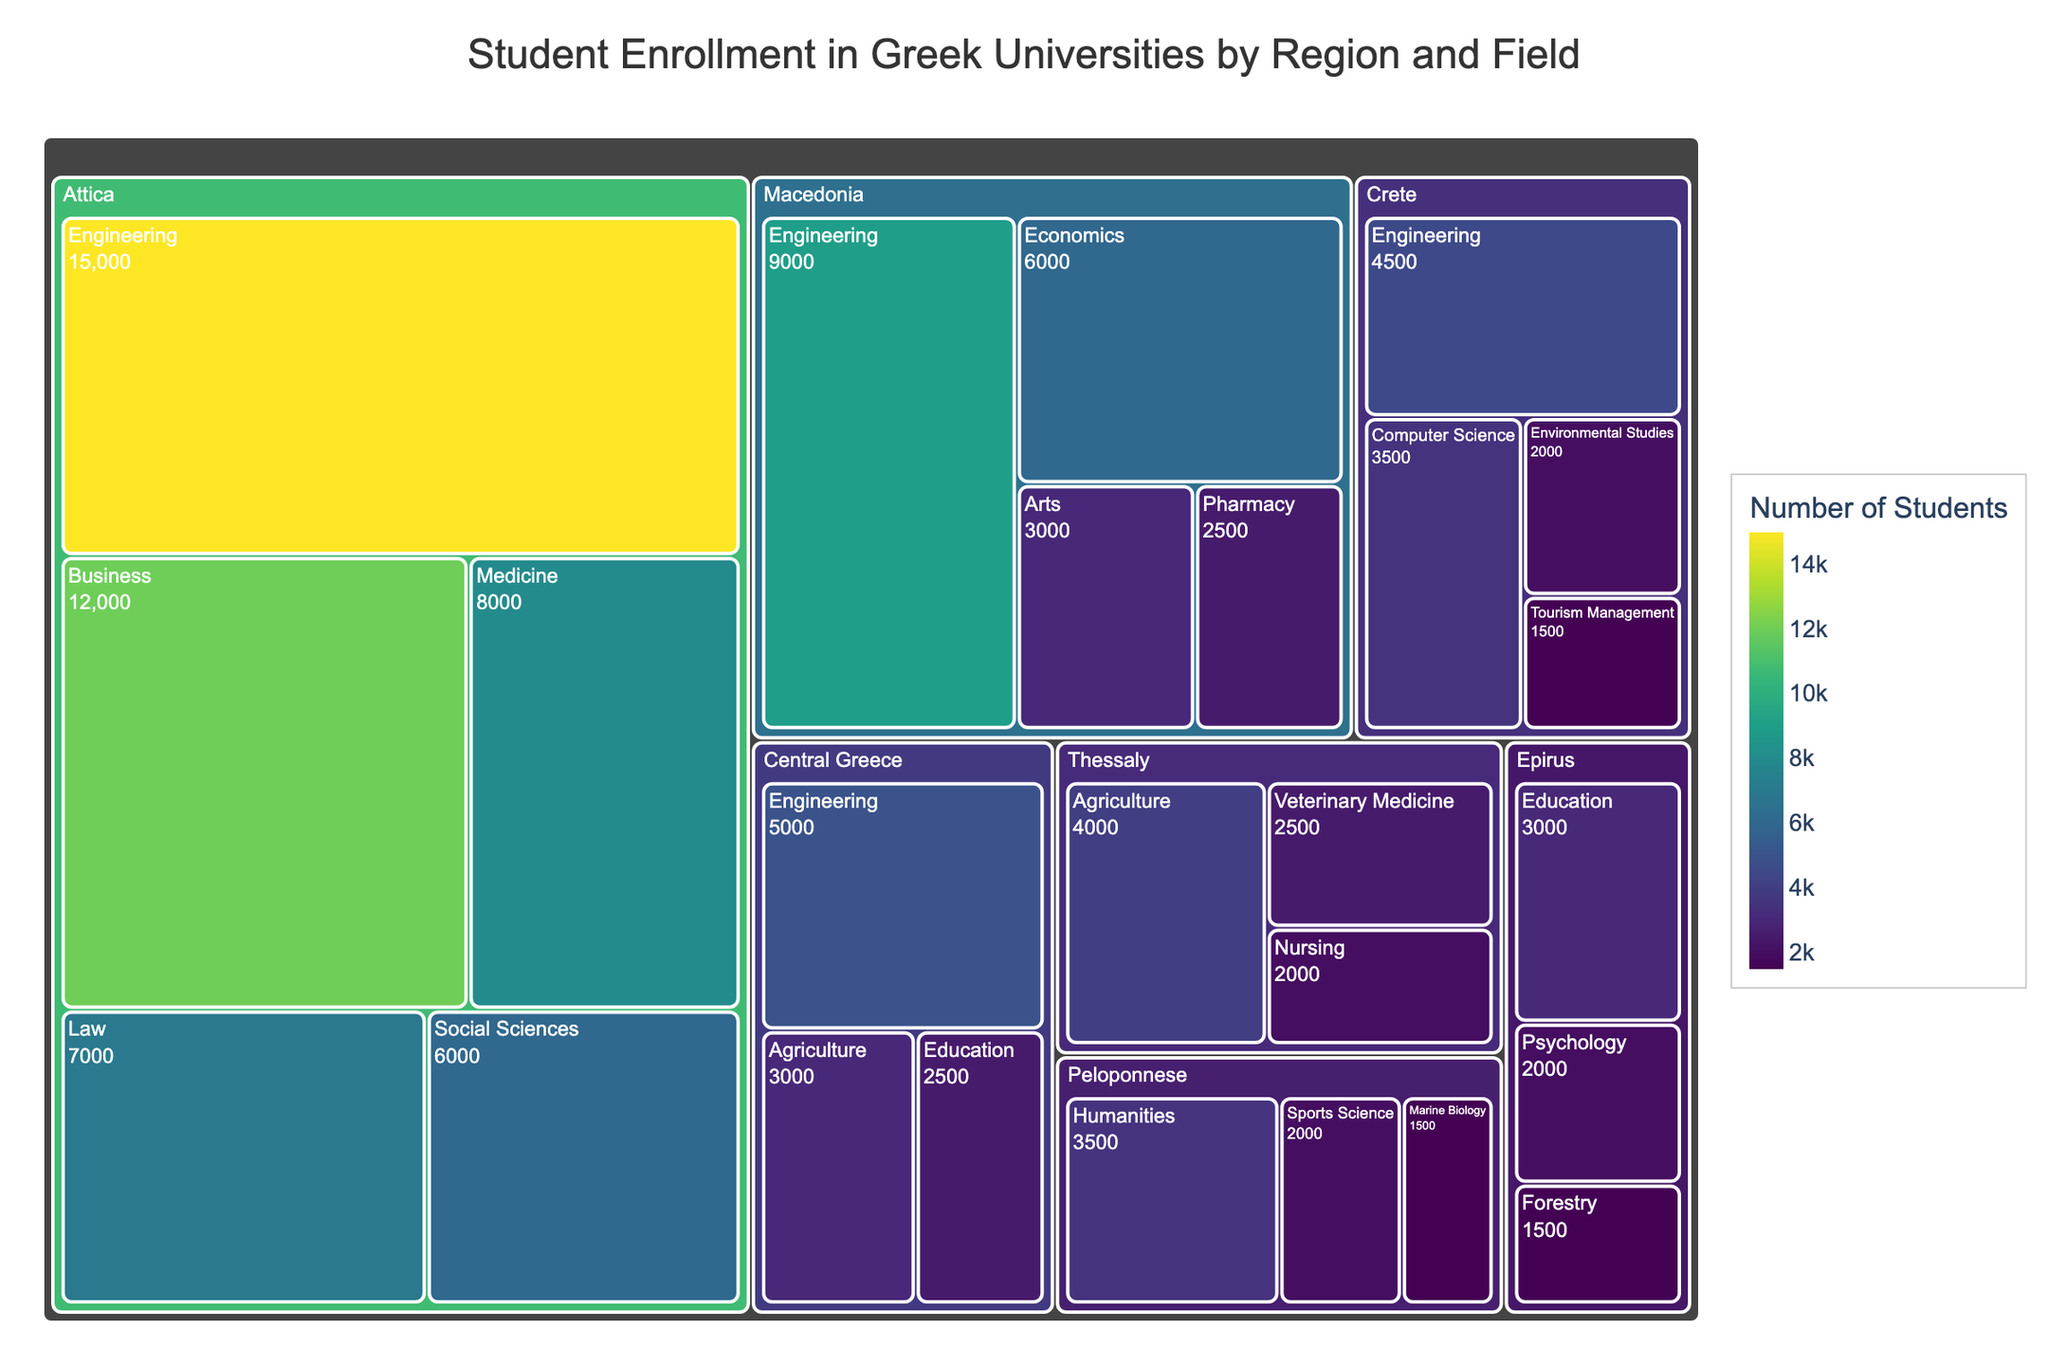What's the total number of students enrolled in Engineering across all regions? Sum the number of students enrolled in Engineering for each region: Attica (15000) + Central Greece (5000) + Crete (4500) + Macedonia (9000).
Answer: 33500 Which region has the highest overall student enrollment? Compare the total student enrollment for each region found in the Treemap. Attica has the highest enrollment.
Answer: Attica How many students are enrolled in Medicine and Veterinary Medicine combined? Medicine (8000) is in Attica, and Veterinary Medicine (2500) is in Thessaly. Sum these values: 8000 + 2500.
Answer: 10500 In which region is the field of Agriculture most popular? Compare the number of students in Agriculture across regions: Central Greece (3000) and Thessaly (4000). Thessaly has more students.
Answer: Thessaly Which field in Crete has the lowest student enrollment? Compare the student enrollments in Crete: Engineering (4500), Computer Science (3500), Environmental Studies (2000), and Tourism Management (1500). Tourism Management is the lowest.
Answer: Tourism Management How does the number of students in Law in Attica compare to the number of students in Nursing in Thessaly? Compare the number of students: Law in Attica (7000) and Nursing in Thessaly (2000). Law has more students.
Answer: Law has more students What's the total number of students enrolled in the regions spanning Peloponnese and Epirus? Sum the total students: Peloponnese (7000) + Epirus (6500).
Answer: 13500 What's the difference in student enrollment between Engineering in Attica and Humanities in Peloponnese? Engineering in Attica has 15000 students, and Humanities in Peloponnese has 3500 students. Subtract 3500 from 15000.
Answer: 11500 Is the number of students in Business in Attica greater than the total number of students in Epirus? Business in Attica has 12000 students, while the total in Epirus is the sum of Education (3000), Psychology (2000), and Forestry (1500): 6500. 12000 is greater than 6500.
Answer: Yes Which region has the most diverse range of fields of study based on the treemap? Count the distinct fields of study shown in the treemap for each region. Attica has the most with 5 fields: Engineering, Business, Medicine, Law, and Social Sciences.
Answer: Attica 